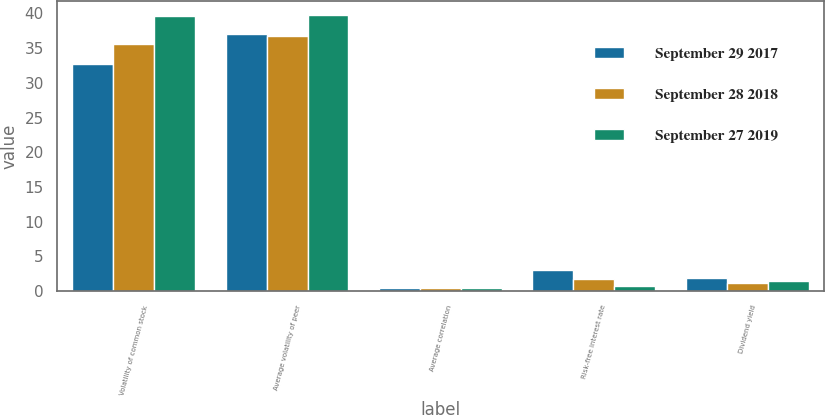Convert chart to OTSL. <chart><loc_0><loc_0><loc_500><loc_500><stacked_bar_chart><ecel><fcel>Volatility of common stock<fcel>Average volatility of peer<fcel>Average correlation<fcel>Risk-free interest rate<fcel>Dividend yield<nl><fcel>September 29 2017<fcel>32.65<fcel>37.07<fcel>0.47<fcel>2.98<fcel>1.84<nl><fcel>September 28 2018<fcel>35.54<fcel>36.78<fcel>0.47<fcel>1.74<fcel>1.15<nl><fcel>September 27 2019<fcel>39.6<fcel>39.78<fcel>0.42<fcel>0.68<fcel>1.44<nl></chart> 